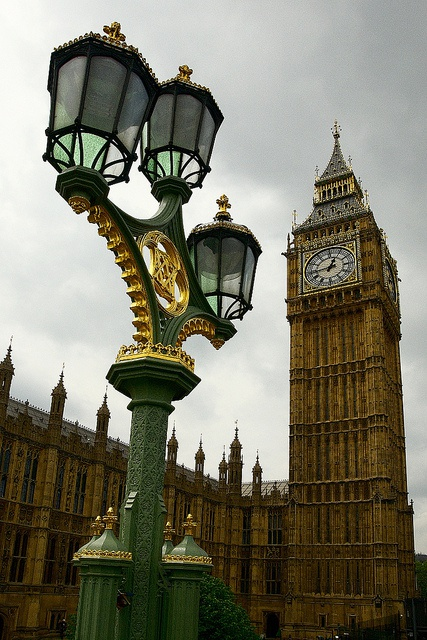Describe the objects in this image and their specific colors. I can see clock in white, gray, darkgray, and black tones and clock in white, black, gray, and olive tones in this image. 